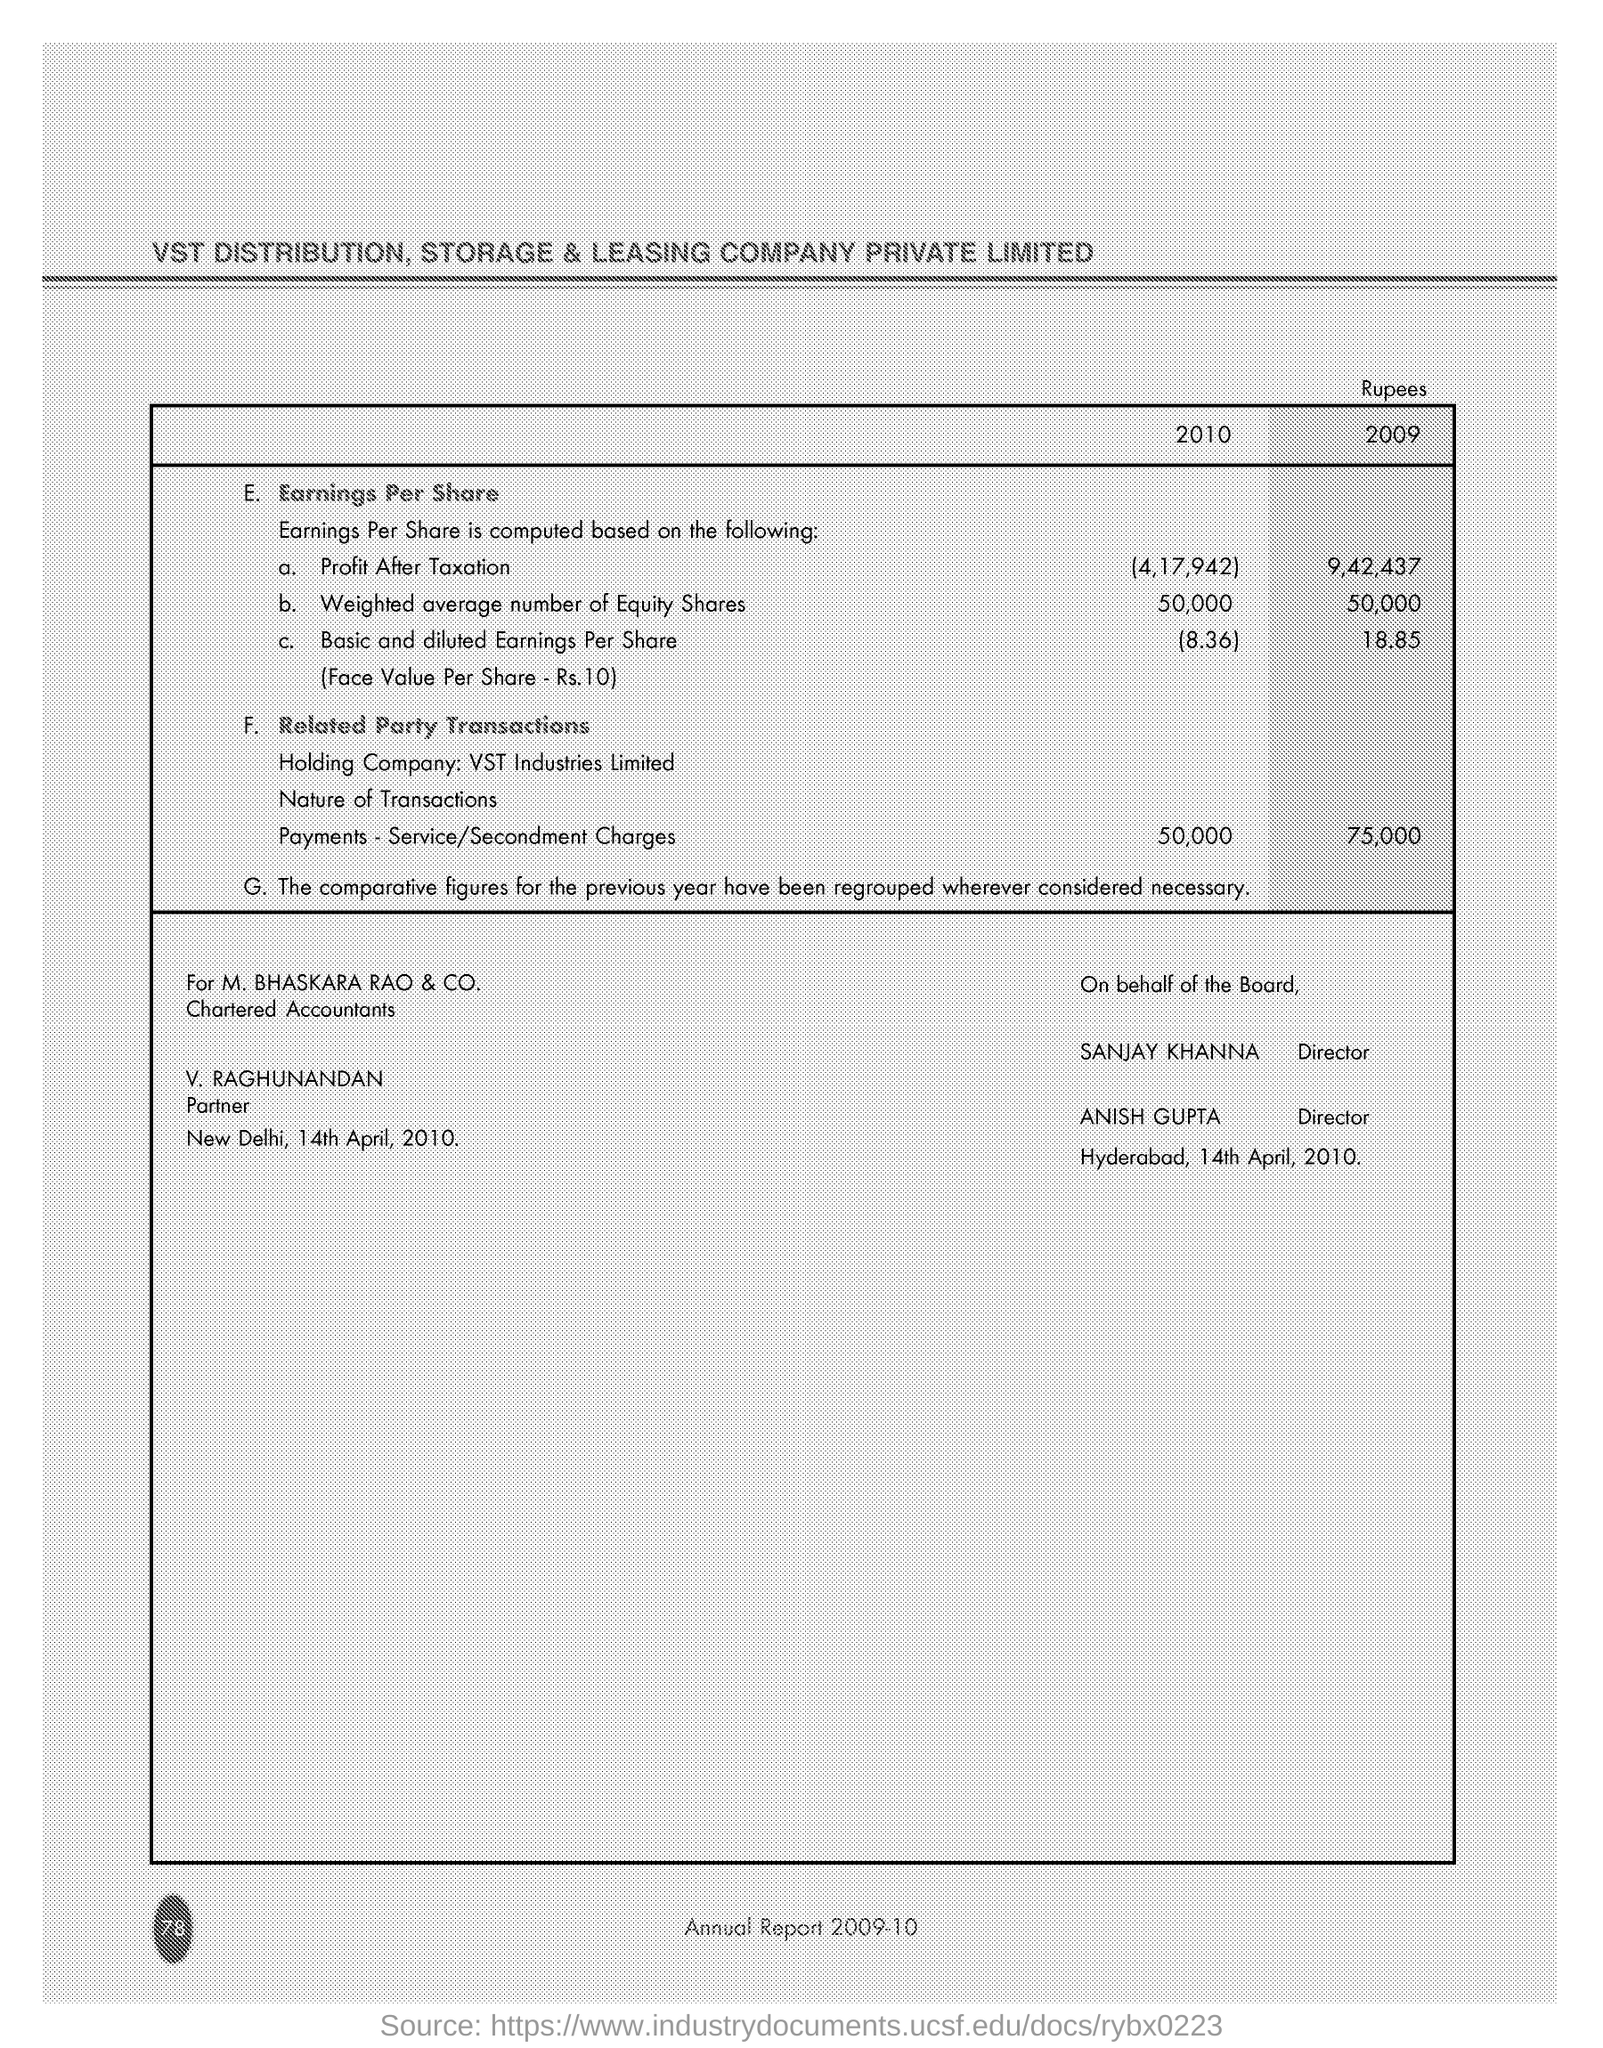Draw attention to some important aspects in this diagram. The title of the document is "VST Distribution, Storage & Leasing Company Private Limited. Raghunandan is the partner. In 2010, the profit after taxation was approximately 4,17,942. The date mentioned at the bottom of the document is 14th April, 2010. 